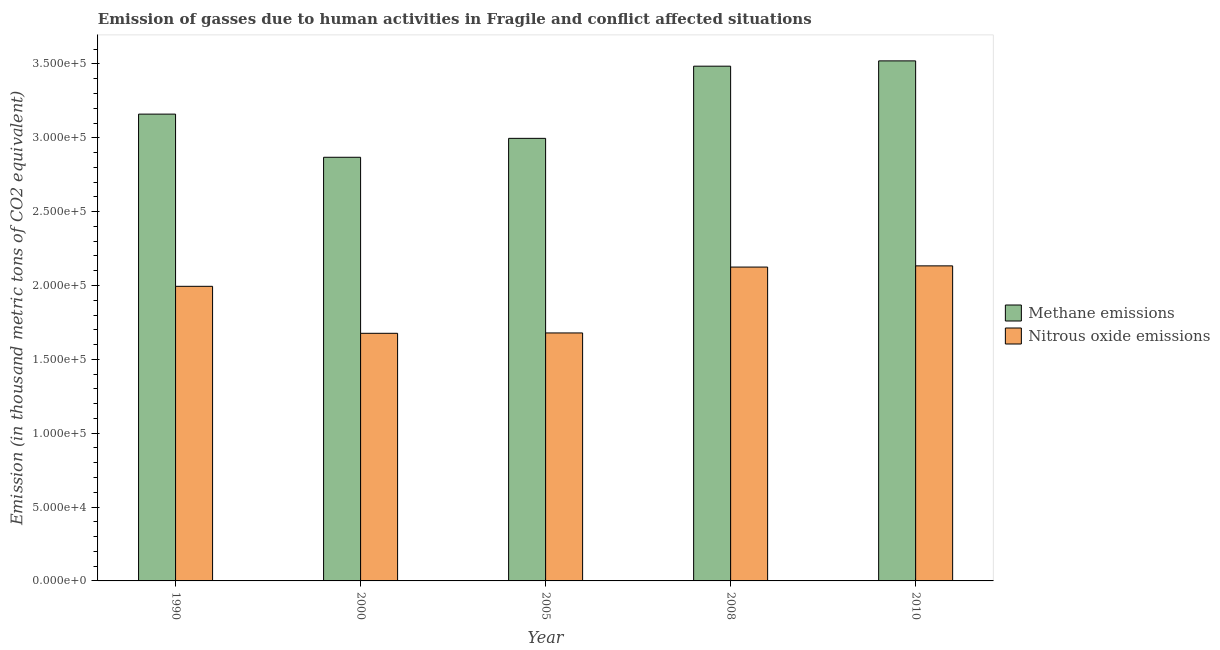How many groups of bars are there?
Ensure brevity in your answer.  5. What is the label of the 3rd group of bars from the left?
Give a very brief answer. 2005. What is the amount of nitrous oxide emissions in 2005?
Offer a very short reply. 1.68e+05. Across all years, what is the maximum amount of nitrous oxide emissions?
Provide a short and direct response. 2.13e+05. Across all years, what is the minimum amount of nitrous oxide emissions?
Your answer should be very brief. 1.68e+05. In which year was the amount of methane emissions maximum?
Give a very brief answer. 2010. What is the total amount of methane emissions in the graph?
Make the answer very short. 1.60e+06. What is the difference between the amount of methane emissions in 1990 and that in 2008?
Ensure brevity in your answer.  -3.24e+04. What is the difference between the amount of methane emissions in 2005 and the amount of nitrous oxide emissions in 2010?
Offer a terse response. -5.24e+04. What is the average amount of nitrous oxide emissions per year?
Your answer should be very brief. 1.92e+05. In how many years, is the amount of nitrous oxide emissions greater than 330000 thousand metric tons?
Give a very brief answer. 0. What is the ratio of the amount of nitrous oxide emissions in 2005 to that in 2008?
Your answer should be very brief. 0.79. What is the difference between the highest and the second highest amount of methane emissions?
Ensure brevity in your answer.  3591.7. What is the difference between the highest and the lowest amount of methane emissions?
Give a very brief answer. 6.53e+04. Is the sum of the amount of nitrous oxide emissions in 2008 and 2010 greater than the maximum amount of methane emissions across all years?
Keep it short and to the point. Yes. What does the 1st bar from the left in 2005 represents?
Offer a very short reply. Methane emissions. What does the 1st bar from the right in 2005 represents?
Make the answer very short. Nitrous oxide emissions. How many bars are there?
Offer a terse response. 10. Are all the bars in the graph horizontal?
Offer a very short reply. No. How many years are there in the graph?
Your answer should be very brief. 5. Are the values on the major ticks of Y-axis written in scientific E-notation?
Provide a succinct answer. Yes. Does the graph contain any zero values?
Provide a succinct answer. No. How many legend labels are there?
Make the answer very short. 2. How are the legend labels stacked?
Offer a terse response. Vertical. What is the title of the graph?
Your response must be concise. Emission of gasses due to human activities in Fragile and conflict affected situations. What is the label or title of the Y-axis?
Give a very brief answer. Emission (in thousand metric tons of CO2 equivalent). What is the Emission (in thousand metric tons of CO2 equivalent) of Methane emissions in 1990?
Keep it short and to the point. 3.16e+05. What is the Emission (in thousand metric tons of CO2 equivalent) in Nitrous oxide emissions in 1990?
Your answer should be very brief. 1.99e+05. What is the Emission (in thousand metric tons of CO2 equivalent) in Methane emissions in 2000?
Offer a terse response. 2.87e+05. What is the Emission (in thousand metric tons of CO2 equivalent) in Nitrous oxide emissions in 2000?
Provide a short and direct response. 1.68e+05. What is the Emission (in thousand metric tons of CO2 equivalent) of Methane emissions in 2005?
Your answer should be compact. 3.00e+05. What is the Emission (in thousand metric tons of CO2 equivalent) of Nitrous oxide emissions in 2005?
Make the answer very short. 1.68e+05. What is the Emission (in thousand metric tons of CO2 equivalent) in Methane emissions in 2008?
Your response must be concise. 3.48e+05. What is the Emission (in thousand metric tons of CO2 equivalent) of Nitrous oxide emissions in 2008?
Give a very brief answer. 2.12e+05. What is the Emission (in thousand metric tons of CO2 equivalent) in Methane emissions in 2010?
Offer a very short reply. 3.52e+05. What is the Emission (in thousand metric tons of CO2 equivalent) of Nitrous oxide emissions in 2010?
Give a very brief answer. 2.13e+05. Across all years, what is the maximum Emission (in thousand metric tons of CO2 equivalent) of Methane emissions?
Offer a terse response. 3.52e+05. Across all years, what is the maximum Emission (in thousand metric tons of CO2 equivalent) of Nitrous oxide emissions?
Provide a succinct answer. 2.13e+05. Across all years, what is the minimum Emission (in thousand metric tons of CO2 equivalent) in Methane emissions?
Provide a succinct answer. 2.87e+05. Across all years, what is the minimum Emission (in thousand metric tons of CO2 equivalent) in Nitrous oxide emissions?
Offer a terse response. 1.68e+05. What is the total Emission (in thousand metric tons of CO2 equivalent) in Methane emissions in the graph?
Keep it short and to the point. 1.60e+06. What is the total Emission (in thousand metric tons of CO2 equivalent) of Nitrous oxide emissions in the graph?
Keep it short and to the point. 9.61e+05. What is the difference between the Emission (in thousand metric tons of CO2 equivalent) of Methane emissions in 1990 and that in 2000?
Your answer should be very brief. 2.92e+04. What is the difference between the Emission (in thousand metric tons of CO2 equivalent) of Nitrous oxide emissions in 1990 and that in 2000?
Provide a succinct answer. 3.18e+04. What is the difference between the Emission (in thousand metric tons of CO2 equivalent) of Methane emissions in 1990 and that in 2005?
Provide a succinct answer. 1.64e+04. What is the difference between the Emission (in thousand metric tons of CO2 equivalent) of Nitrous oxide emissions in 1990 and that in 2005?
Ensure brevity in your answer.  3.16e+04. What is the difference between the Emission (in thousand metric tons of CO2 equivalent) in Methane emissions in 1990 and that in 2008?
Provide a short and direct response. -3.24e+04. What is the difference between the Emission (in thousand metric tons of CO2 equivalent) of Nitrous oxide emissions in 1990 and that in 2008?
Your answer should be very brief. -1.30e+04. What is the difference between the Emission (in thousand metric tons of CO2 equivalent) in Methane emissions in 1990 and that in 2010?
Your answer should be very brief. -3.60e+04. What is the difference between the Emission (in thousand metric tons of CO2 equivalent) of Nitrous oxide emissions in 1990 and that in 2010?
Ensure brevity in your answer.  -1.38e+04. What is the difference between the Emission (in thousand metric tons of CO2 equivalent) of Methane emissions in 2000 and that in 2005?
Make the answer very short. -1.28e+04. What is the difference between the Emission (in thousand metric tons of CO2 equivalent) in Nitrous oxide emissions in 2000 and that in 2005?
Ensure brevity in your answer.  -238.1. What is the difference between the Emission (in thousand metric tons of CO2 equivalent) in Methane emissions in 2000 and that in 2008?
Offer a terse response. -6.17e+04. What is the difference between the Emission (in thousand metric tons of CO2 equivalent) of Nitrous oxide emissions in 2000 and that in 2008?
Your answer should be compact. -4.48e+04. What is the difference between the Emission (in thousand metric tons of CO2 equivalent) in Methane emissions in 2000 and that in 2010?
Give a very brief answer. -6.53e+04. What is the difference between the Emission (in thousand metric tons of CO2 equivalent) of Nitrous oxide emissions in 2000 and that in 2010?
Ensure brevity in your answer.  -4.57e+04. What is the difference between the Emission (in thousand metric tons of CO2 equivalent) in Methane emissions in 2005 and that in 2008?
Your answer should be very brief. -4.89e+04. What is the difference between the Emission (in thousand metric tons of CO2 equivalent) in Nitrous oxide emissions in 2005 and that in 2008?
Make the answer very short. -4.46e+04. What is the difference between the Emission (in thousand metric tons of CO2 equivalent) in Methane emissions in 2005 and that in 2010?
Offer a terse response. -5.24e+04. What is the difference between the Emission (in thousand metric tons of CO2 equivalent) of Nitrous oxide emissions in 2005 and that in 2010?
Your answer should be very brief. -4.54e+04. What is the difference between the Emission (in thousand metric tons of CO2 equivalent) in Methane emissions in 2008 and that in 2010?
Your answer should be compact. -3591.7. What is the difference between the Emission (in thousand metric tons of CO2 equivalent) in Nitrous oxide emissions in 2008 and that in 2010?
Keep it short and to the point. -807. What is the difference between the Emission (in thousand metric tons of CO2 equivalent) of Methane emissions in 1990 and the Emission (in thousand metric tons of CO2 equivalent) of Nitrous oxide emissions in 2000?
Provide a succinct answer. 1.48e+05. What is the difference between the Emission (in thousand metric tons of CO2 equivalent) of Methane emissions in 1990 and the Emission (in thousand metric tons of CO2 equivalent) of Nitrous oxide emissions in 2005?
Make the answer very short. 1.48e+05. What is the difference between the Emission (in thousand metric tons of CO2 equivalent) in Methane emissions in 1990 and the Emission (in thousand metric tons of CO2 equivalent) in Nitrous oxide emissions in 2008?
Give a very brief answer. 1.04e+05. What is the difference between the Emission (in thousand metric tons of CO2 equivalent) of Methane emissions in 1990 and the Emission (in thousand metric tons of CO2 equivalent) of Nitrous oxide emissions in 2010?
Offer a very short reply. 1.03e+05. What is the difference between the Emission (in thousand metric tons of CO2 equivalent) in Methane emissions in 2000 and the Emission (in thousand metric tons of CO2 equivalent) in Nitrous oxide emissions in 2005?
Your response must be concise. 1.19e+05. What is the difference between the Emission (in thousand metric tons of CO2 equivalent) of Methane emissions in 2000 and the Emission (in thousand metric tons of CO2 equivalent) of Nitrous oxide emissions in 2008?
Your answer should be very brief. 7.43e+04. What is the difference between the Emission (in thousand metric tons of CO2 equivalent) in Methane emissions in 2000 and the Emission (in thousand metric tons of CO2 equivalent) in Nitrous oxide emissions in 2010?
Provide a short and direct response. 7.35e+04. What is the difference between the Emission (in thousand metric tons of CO2 equivalent) in Methane emissions in 2005 and the Emission (in thousand metric tons of CO2 equivalent) in Nitrous oxide emissions in 2008?
Give a very brief answer. 8.71e+04. What is the difference between the Emission (in thousand metric tons of CO2 equivalent) of Methane emissions in 2005 and the Emission (in thousand metric tons of CO2 equivalent) of Nitrous oxide emissions in 2010?
Ensure brevity in your answer.  8.63e+04. What is the difference between the Emission (in thousand metric tons of CO2 equivalent) of Methane emissions in 2008 and the Emission (in thousand metric tons of CO2 equivalent) of Nitrous oxide emissions in 2010?
Ensure brevity in your answer.  1.35e+05. What is the average Emission (in thousand metric tons of CO2 equivalent) in Methane emissions per year?
Provide a succinct answer. 3.21e+05. What is the average Emission (in thousand metric tons of CO2 equivalent) of Nitrous oxide emissions per year?
Give a very brief answer. 1.92e+05. In the year 1990, what is the difference between the Emission (in thousand metric tons of CO2 equivalent) in Methane emissions and Emission (in thousand metric tons of CO2 equivalent) in Nitrous oxide emissions?
Your answer should be very brief. 1.17e+05. In the year 2000, what is the difference between the Emission (in thousand metric tons of CO2 equivalent) in Methane emissions and Emission (in thousand metric tons of CO2 equivalent) in Nitrous oxide emissions?
Your answer should be compact. 1.19e+05. In the year 2005, what is the difference between the Emission (in thousand metric tons of CO2 equivalent) of Methane emissions and Emission (in thousand metric tons of CO2 equivalent) of Nitrous oxide emissions?
Offer a terse response. 1.32e+05. In the year 2008, what is the difference between the Emission (in thousand metric tons of CO2 equivalent) of Methane emissions and Emission (in thousand metric tons of CO2 equivalent) of Nitrous oxide emissions?
Your answer should be very brief. 1.36e+05. In the year 2010, what is the difference between the Emission (in thousand metric tons of CO2 equivalent) in Methane emissions and Emission (in thousand metric tons of CO2 equivalent) in Nitrous oxide emissions?
Your response must be concise. 1.39e+05. What is the ratio of the Emission (in thousand metric tons of CO2 equivalent) in Methane emissions in 1990 to that in 2000?
Ensure brevity in your answer.  1.1. What is the ratio of the Emission (in thousand metric tons of CO2 equivalent) in Nitrous oxide emissions in 1990 to that in 2000?
Provide a succinct answer. 1.19. What is the ratio of the Emission (in thousand metric tons of CO2 equivalent) in Methane emissions in 1990 to that in 2005?
Make the answer very short. 1.05. What is the ratio of the Emission (in thousand metric tons of CO2 equivalent) of Nitrous oxide emissions in 1990 to that in 2005?
Your answer should be compact. 1.19. What is the ratio of the Emission (in thousand metric tons of CO2 equivalent) in Methane emissions in 1990 to that in 2008?
Provide a short and direct response. 0.91. What is the ratio of the Emission (in thousand metric tons of CO2 equivalent) in Nitrous oxide emissions in 1990 to that in 2008?
Keep it short and to the point. 0.94. What is the ratio of the Emission (in thousand metric tons of CO2 equivalent) in Methane emissions in 1990 to that in 2010?
Provide a short and direct response. 0.9. What is the ratio of the Emission (in thousand metric tons of CO2 equivalent) of Nitrous oxide emissions in 1990 to that in 2010?
Offer a very short reply. 0.94. What is the ratio of the Emission (in thousand metric tons of CO2 equivalent) of Methane emissions in 2000 to that in 2005?
Your response must be concise. 0.96. What is the ratio of the Emission (in thousand metric tons of CO2 equivalent) in Nitrous oxide emissions in 2000 to that in 2005?
Give a very brief answer. 1. What is the ratio of the Emission (in thousand metric tons of CO2 equivalent) of Methane emissions in 2000 to that in 2008?
Make the answer very short. 0.82. What is the ratio of the Emission (in thousand metric tons of CO2 equivalent) of Nitrous oxide emissions in 2000 to that in 2008?
Offer a very short reply. 0.79. What is the ratio of the Emission (in thousand metric tons of CO2 equivalent) of Methane emissions in 2000 to that in 2010?
Your answer should be very brief. 0.81. What is the ratio of the Emission (in thousand metric tons of CO2 equivalent) in Nitrous oxide emissions in 2000 to that in 2010?
Provide a short and direct response. 0.79. What is the ratio of the Emission (in thousand metric tons of CO2 equivalent) in Methane emissions in 2005 to that in 2008?
Your response must be concise. 0.86. What is the ratio of the Emission (in thousand metric tons of CO2 equivalent) in Nitrous oxide emissions in 2005 to that in 2008?
Your answer should be very brief. 0.79. What is the ratio of the Emission (in thousand metric tons of CO2 equivalent) of Methane emissions in 2005 to that in 2010?
Give a very brief answer. 0.85. What is the ratio of the Emission (in thousand metric tons of CO2 equivalent) of Nitrous oxide emissions in 2005 to that in 2010?
Make the answer very short. 0.79. What is the ratio of the Emission (in thousand metric tons of CO2 equivalent) in Methane emissions in 2008 to that in 2010?
Ensure brevity in your answer.  0.99. What is the difference between the highest and the second highest Emission (in thousand metric tons of CO2 equivalent) of Methane emissions?
Ensure brevity in your answer.  3591.7. What is the difference between the highest and the second highest Emission (in thousand metric tons of CO2 equivalent) of Nitrous oxide emissions?
Your answer should be compact. 807. What is the difference between the highest and the lowest Emission (in thousand metric tons of CO2 equivalent) of Methane emissions?
Make the answer very short. 6.53e+04. What is the difference between the highest and the lowest Emission (in thousand metric tons of CO2 equivalent) of Nitrous oxide emissions?
Provide a short and direct response. 4.57e+04. 